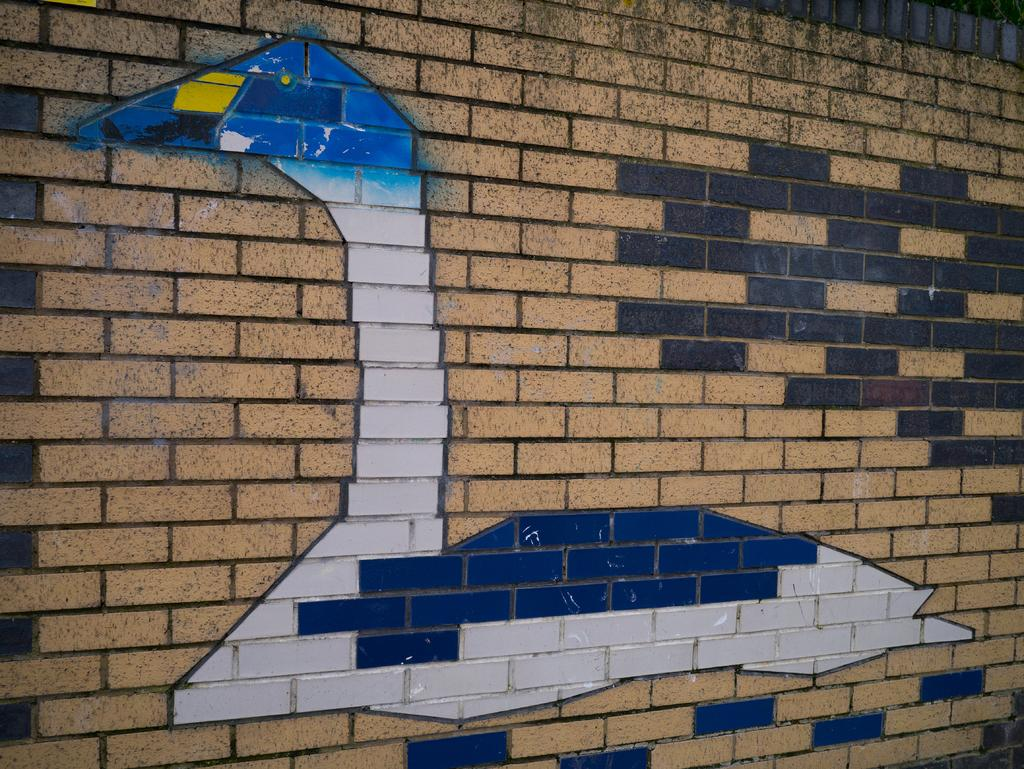What type of structure is visible in the image? There is a brick wall in the image. What is depicted on the brick wall? There is a painting of a duck on the wall. What can be said about the colors used in the painting? The painting uses different colors. How many toes does the woman in the painting have? There is no woman present in the image, only a painting of a duck. 